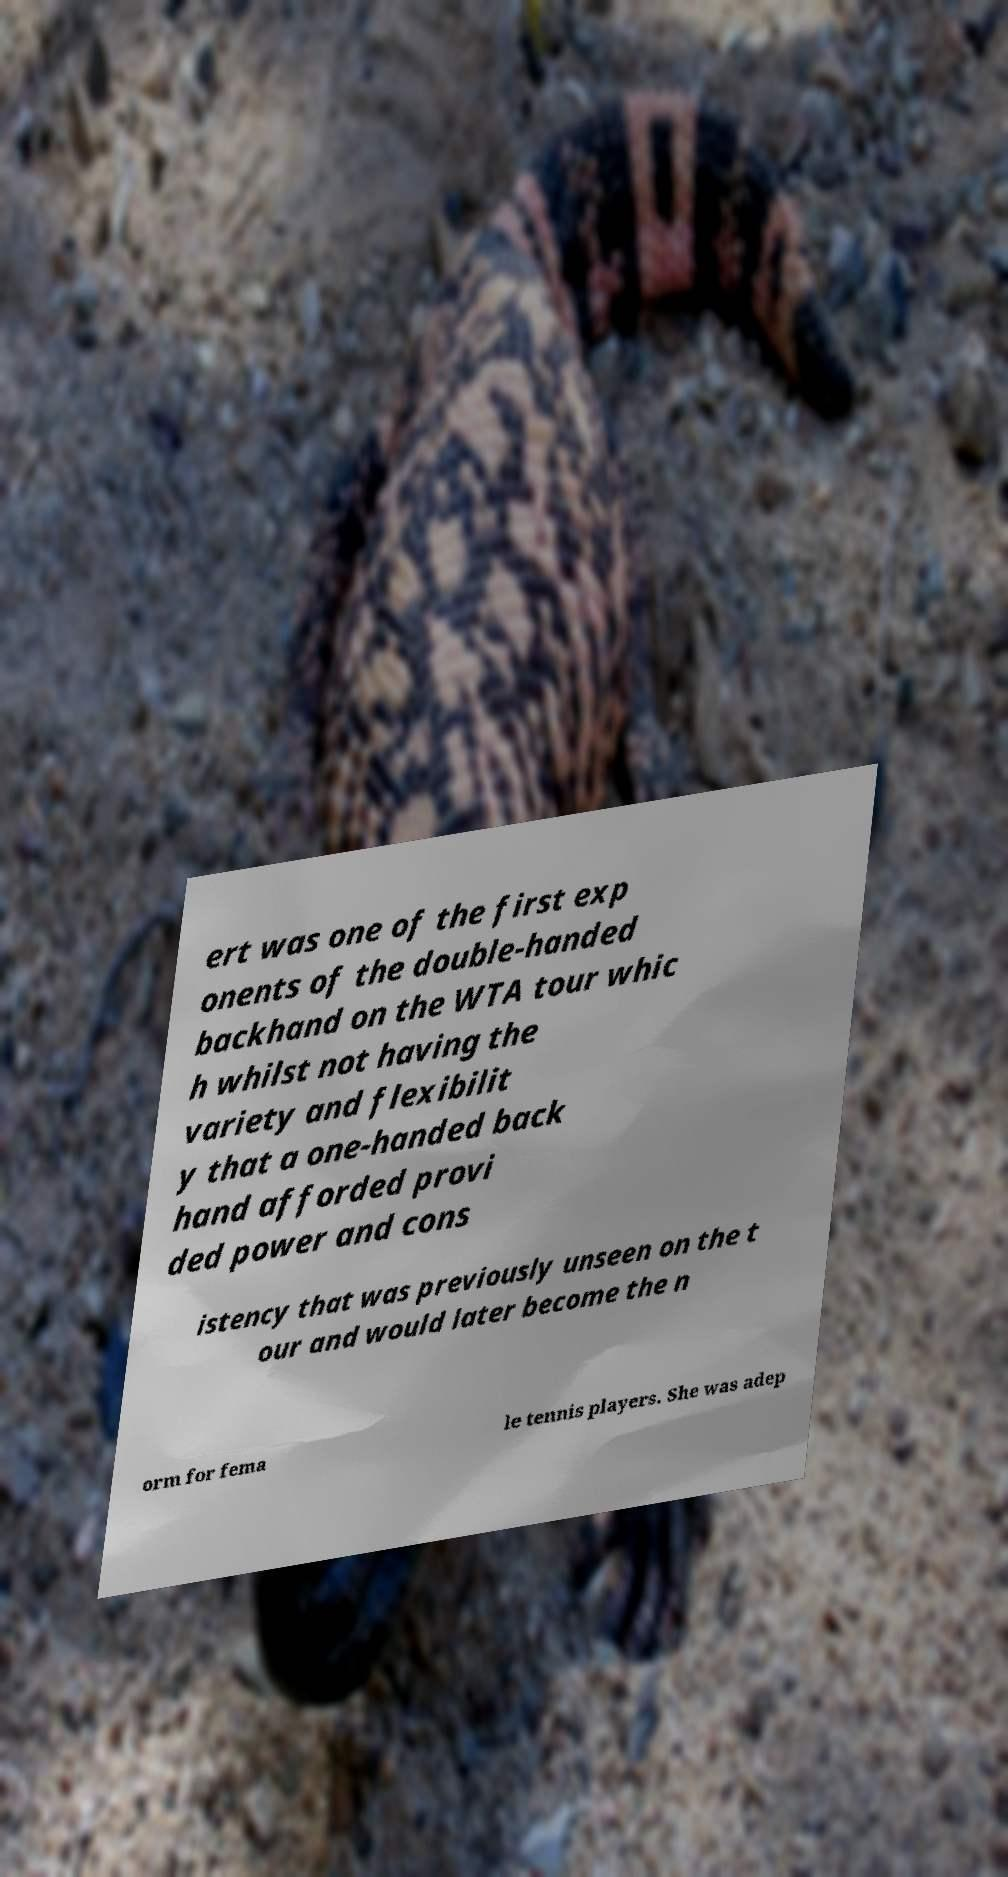Can you accurately transcribe the text from the provided image for me? ert was one of the first exp onents of the double-handed backhand on the WTA tour whic h whilst not having the variety and flexibilit y that a one-handed back hand afforded provi ded power and cons istency that was previously unseen on the t our and would later become the n orm for fema le tennis players. She was adep 